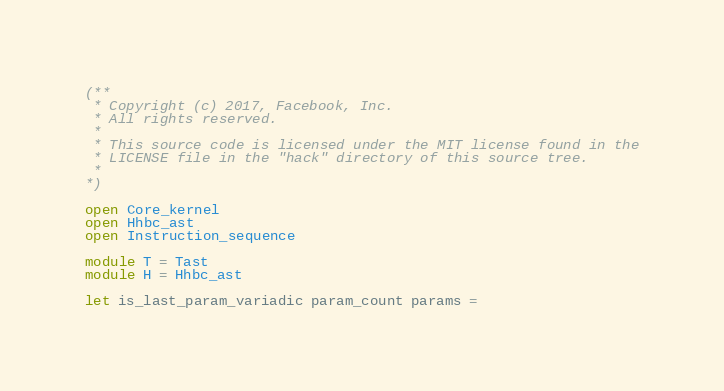Convert code to text. <code><loc_0><loc_0><loc_500><loc_500><_OCaml_>(**
 * Copyright (c) 2017, Facebook, Inc.
 * All rights reserved.
 *
 * This source code is licensed under the MIT license found in the
 * LICENSE file in the "hack" directory of this source tree.
 *
*)

open Core_kernel
open Hhbc_ast
open Instruction_sequence

module T = Tast
module H = Hhbc_ast

let is_last_param_variadic param_count params =</code> 